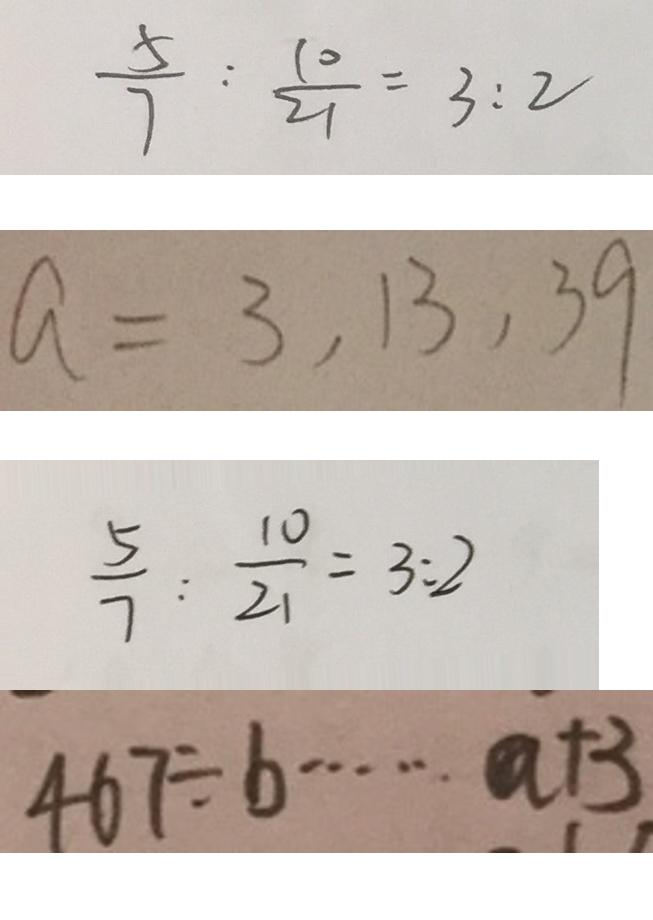Convert formula to latex. <formula><loc_0><loc_0><loc_500><loc_500>\frac { 5 } { 7 } : \frac { 1 0 } { 2 1 } = 3 : 2 
 a = 3 , 1 3 , 3 9 
 \frac { 5 } { 7 } : \frac { 1 0 } { 2 1 } = 3 : 2 
 4 6 7 \div b \cdots a + 3</formula> 